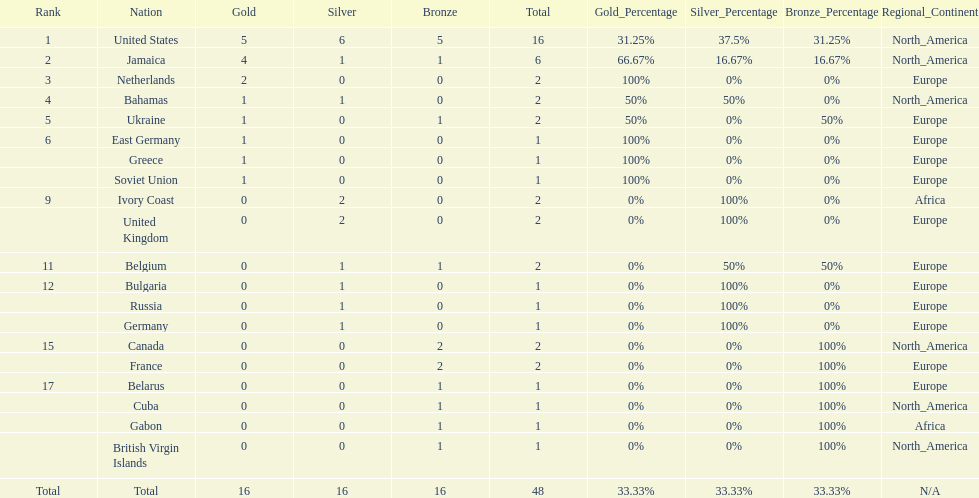How many nations won more than one silver medal? 3. 